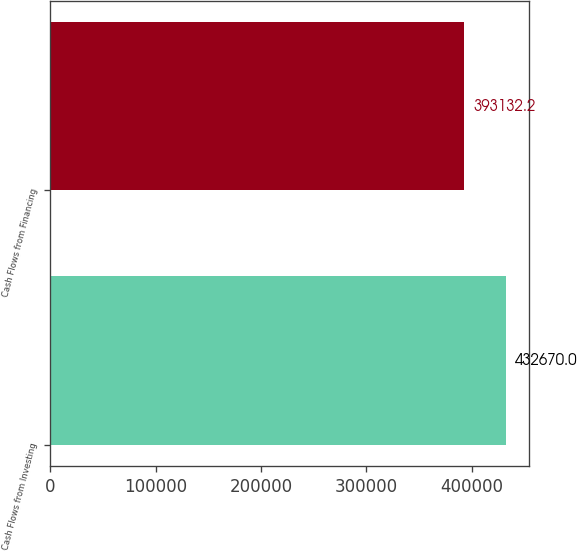Convert chart. <chart><loc_0><loc_0><loc_500><loc_500><bar_chart><fcel>Cash Flows from Investing<fcel>Cash Flows from Financing<nl><fcel>432670<fcel>393132<nl></chart> 